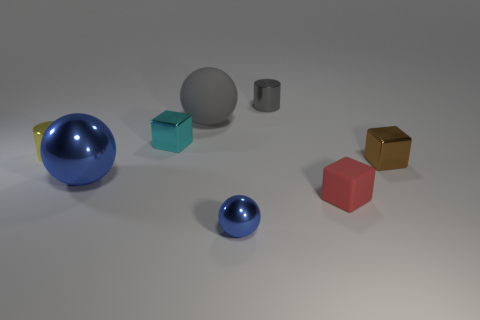There is a shiny thing that is both to the left of the gray sphere and on the right side of the big metal sphere; what color is it?
Make the answer very short. Cyan. What number of other objects are the same color as the big rubber object?
Keep it short and to the point. 1. There is a sphere that is behind the cylinder that is in front of the small cylinder that is right of the tiny shiny ball; what is its material?
Make the answer very short. Rubber. How many blocks are either gray things or large gray rubber objects?
Give a very brief answer. 0. How many gray cylinders are to the left of the big ball in front of the thing on the right side of the red thing?
Your answer should be very brief. 0. Do the red thing and the small cyan shiny object have the same shape?
Offer a terse response. Yes. Does the big thing to the left of the large gray ball have the same material as the tiny block that is behind the tiny brown metallic cube?
Your answer should be compact. Yes. How many objects are cylinders that are right of the cyan metal block or metal objects in front of the big matte sphere?
Keep it short and to the point. 6. How many tiny yellow cubes are there?
Provide a short and direct response. 0. Is there a blue metal ball that has the same size as the cyan object?
Your answer should be very brief. Yes. 